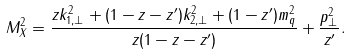Convert formula to latex. <formula><loc_0><loc_0><loc_500><loc_500>M _ { X } ^ { 2 } = \frac { z k _ { 1 , \perp } ^ { 2 } + ( 1 - z - z ^ { \prime } ) k _ { 2 , \perp } ^ { 2 } + ( 1 - z ^ { \prime } ) m _ { q } ^ { 2 } } { z ( 1 - z - z ^ { \prime } ) } + \frac { p _ { \perp } ^ { 2 } } { z ^ { \prime } } .</formula> 